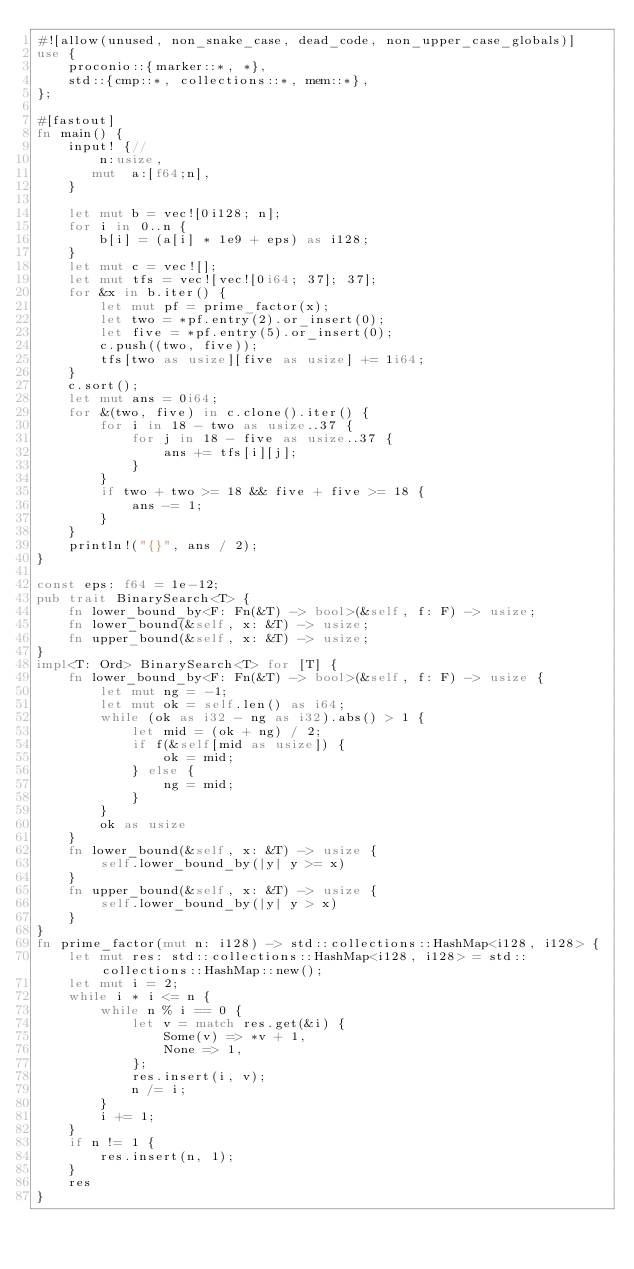Convert code to text. <code><loc_0><loc_0><loc_500><loc_500><_Rust_>#![allow(unused, non_snake_case, dead_code, non_upper_case_globals)]
use {
    proconio::{marker::*, *},
    std::{cmp::*, collections::*, mem::*},
};

#[fastout]
fn main() {
    input! {//
        n:usize,
       mut  a:[f64;n],
    }

    let mut b = vec![0i128; n];
    for i in 0..n {
        b[i] = (a[i] * 1e9 + eps) as i128;
    }
    let mut c = vec![];
    let mut tfs = vec![vec![0i64; 37]; 37];
    for &x in b.iter() {
        let mut pf = prime_factor(x);
        let two = *pf.entry(2).or_insert(0);
        let five = *pf.entry(5).or_insert(0);
        c.push((two, five));
        tfs[two as usize][five as usize] += 1i64;
    }
    c.sort();
    let mut ans = 0i64;
    for &(two, five) in c.clone().iter() {
        for i in 18 - two as usize..37 {
            for j in 18 - five as usize..37 {
                ans += tfs[i][j];
            }
        }
        if two + two >= 18 && five + five >= 18 {
            ans -= 1;
        }
    }
    println!("{}", ans / 2);
}

const eps: f64 = 1e-12;
pub trait BinarySearch<T> {
    fn lower_bound_by<F: Fn(&T) -> bool>(&self, f: F) -> usize;
    fn lower_bound(&self, x: &T) -> usize;
    fn upper_bound(&self, x: &T) -> usize;
}
impl<T: Ord> BinarySearch<T> for [T] {
    fn lower_bound_by<F: Fn(&T) -> bool>(&self, f: F) -> usize {
        let mut ng = -1;
        let mut ok = self.len() as i64;
        while (ok as i32 - ng as i32).abs() > 1 {
            let mid = (ok + ng) / 2;
            if f(&self[mid as usize]) {
                ok = mid;
            } else {
                ng = mid;
            }
        }
        ok as usize
    }
    fn lower_bound(&self, x: &T) -> usize {
        self.lower_bound_by(|y| y >= x)
    }
    fn upper_bound(&self, x: &T) -> usize {
        self.lower_bound_by(|y| y > x)
    }
}
fn prime_factor(mut n: i128) -> std::collections::HashMap<i128, i128> {
    let mut res: std::collections::HashMap<i128, i128> = std::collections::HashMap::new();
    let mut i = 2;
    while i * i <= n {
        while n % i == 0 {
            let v = match res.get(&i) {
                Some(v) => *v + 1,
                None => 1,
            };
            res.insert(i, v);
            n /= i;
        }
        i += 1;
    }
    if n != 1 {
        res.insert(n, 1);
    }
    res
}
</code> 